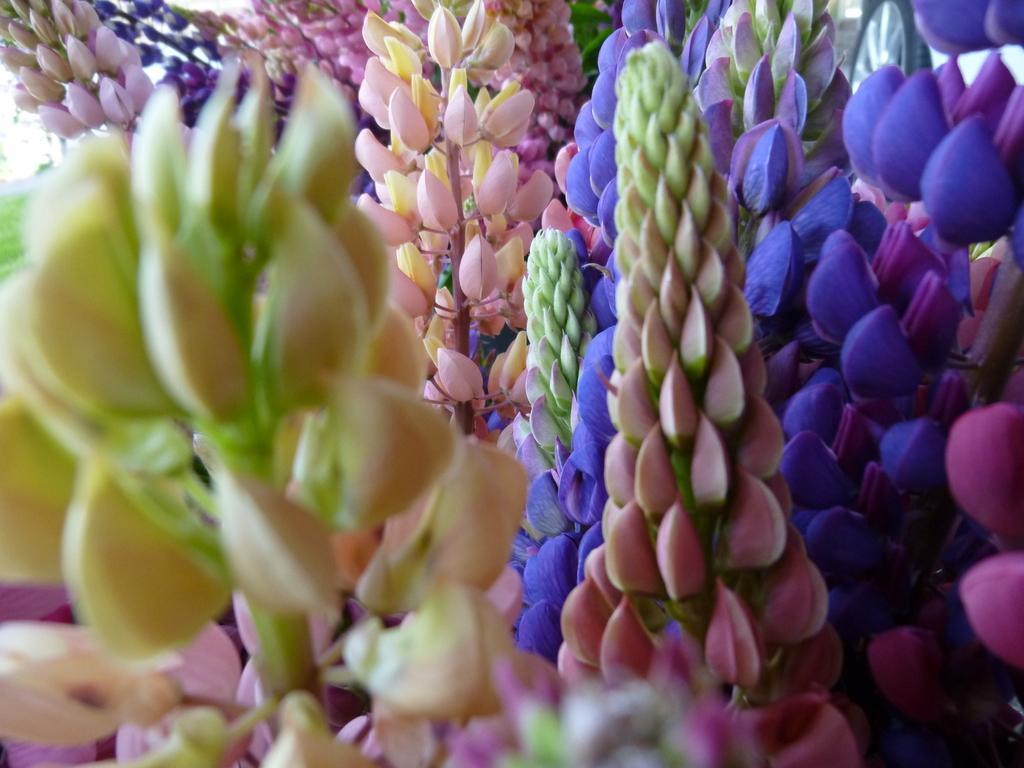Can you describe this image briefly? In this image there are many plants with lavender flowers. They are in purple color. 